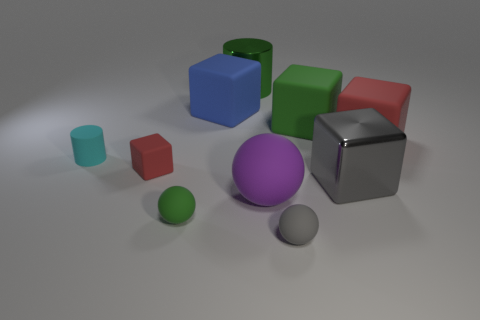Subtract all gray cubes. How many cubes are left? 4 Subtract all large blue matte blocks. How many blocks are left? 4 Subtract all cyan cubes. Subtract all purple cylinders. How many cubes are left? 5 Subtract all spheres. How many objects are left? 7 Subtract all big cyan cubes. Subtract all large gray objects. How many objects are left? 9 Add 6 small red rubber blocks. How many small red rubber blocks are left? 7 Add 9 cyan shiny cylinders. How many cyan shiny cylinders exist? 9 Subtract 1 cyan cylinders. How many objects are left? 9 